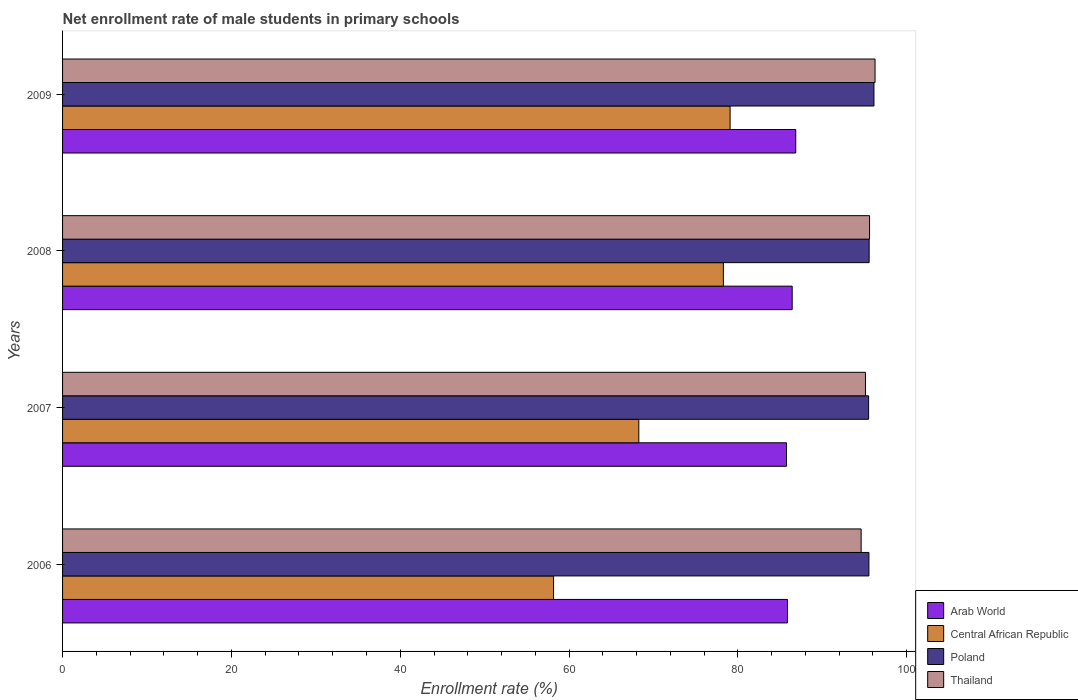How many groups of bars are there?
Your answer should be compact. 4. Are the number of bars on each tick of the Y-axis equal?
Keep it short and to the point. Yes. How many bars are there on the 3rd tick from the top?
Keep it short and to the point. 4. What is the label of the 3rd group of bars from the top?
Your answer should be very brief. 2007. In how many cases, is the number of bars for a given year not equal to the number of legend labels?
Ensure brevity in your answer.  0. What is the net enrollment rate of male students in primary schools in Poland in 2008?
Your answer should be very brief. 95.55. Across all years, what is the maximum net enrollment rate of male students in primary schools in Central African Republic?
Keep it short and to the point. 79.08. Across all years, what is the minimum net enrollment rate of male students in primary schools in Arab World?
Your answer should be very brief. 85.76. In which year was the net enrollment rate of male students in primary schools in Poland maximum?
Ensure brevity in your answer.  2009. In which year was the net enrollment rate of male students in primary schools in Central African Republic minimum?
Offer a terse response. 2006. What is the total net enrollment rate of male students in primary schools in Arab World in the graph?
Make the answer very short. 344.91. What is the difference between the net enrollment rate of male students in primary schools in Thailand in 2006 and that in 2008?
Provide a succinct answer. -1. What is the difference between the net enrollment rate of male students in primary schools in Arab World in 2006 and the net enrollment rate of male students in primary schools in Poland in 2009?
Provide a short and direct response. -10.24. What is the average net enrollment rate of male students in primary schools in Thailand per year?
Your answer should be compact. 95.39. In the year 2007, what is the difference between the net enrollment rate of male students in primary schools in Arab World and net enrollment rate of male students in primary schools in Poland?
Keep it short and to the point. -9.73. In how many years, is the net enrollment rate of male students in primary schools in Arab World greater than 92 %?
Offer a terse response. 0. What is the ratio of the net enrollment rate of male students in primary schools in Poland in 2006 to that in 2008?
Make the answer very short. 1. Is the net enrollment rate of male students in primary schools in Arab World in 2007 less than that in 2008?
Offer a very short reply. Yes. Is the difference between the net enrollment rate of male students in primary schools in Arab World in 2006 and 2007 greater than the difference between the net enrollment rate of male students in primary schools in Poland in 2006 and 2007?
Your answer should be compact. Yes. What is the difference between the highest and the second highest net enrollment rate of male students in primary schools in Poland?
Offer a very short reply. 0.57. What is the difference between the highest and the lowest net enrollment rate of male students in primary schools in Poland?
Your answer should be very brief. 0.63. In how many years, is the net enrollment rate of male students in primary schools in Central African Republic greater than the average net enrollment rate of male students in primary schools in Central African Republic taken over all years?
Your answer should be compact. 2. What does the 4th bar from the top in 2006 represents?
Your response must be concise. Arab World. What does the 4th bar from the bottom in 2009 represents?
Provide a succinct answer. Thailand. Are all the bars in the graph horizontal?
Keep it short and to the point. Yes. How many years are there in the graph?
Offer a very short reply. 4. What is the difference between two consecutive major ticks on the X-axis?
Provide a short and direct response. 20. Are the values on the major ticks of X-axis written in scientific E-notation?
Your answer should be very brief. No. Where does the legend appear in the graph?
Your response must be concise. Bottom right. How are the legend labels stacked?
Offer a very short reply. Vertical. What is the title of the graph?
Keep it short and to the point. Net enrollment rate of male students in primary schools. What is the label or title of the X-axis?
Give a very brief answer. Enrollment rate (%). What is the Enrollment rate (%) of Arab World in 2006?
Offer a very short reply. 85.87. What is the Enrollment rate (%) of Central African Republic in 2006?
Offer a very short reply. 58.16. What is the Enrollment rate (%) in Poland in 2006?
Provide a succinct answer. 95.52. What is the Enrollment rate (%) of Thailand in 2006?
Ensure brevity in your answer.  94.6. What is the Enrollment rate (%) in Arab World in 2007?
Your answer should be very brief. 85.76. What is the Enrollment rate (%) in Central African Republic in 2007?
Give a very brief answer. 68.26. What is the Enrollment rate (%) of Poland in 2007?
Give a very brief answer. 95.48. What is the Enrollment rate (%) of Thailand in 2007?
Provide a short and direct response. 95.11. What is the Enrollment rate (%) of Arab World in 2008?
Make the answer very short. 86.43. What is the Enrollment rate (%) of Central African Republic in 2008?
Make the answer very short. 78.28. What is the Enrollment rate (%) in Poland in 2008?
Make the answer very short. 95.55. What is the Enrollment rate (%) of Thailand in 2008?
Provide a short and direct response. 95.6. What is the Enrollment rate (%) in Arab World in 2009?
Make the answer very short. 86.85. What is the Enrollment rate (%) of Central African Republic in 2009?
Make the answer very short. 79.08. What is the Enrollment rate (%) in Poland in 2009?
Provide a short and direct response. 96.12. What is the Enrollment rate (%) in Thailand in 2009?
Make the answer very short. 96.25. Across all years, what is the maximum Enrollment rate (%) of Arab World?
Provide a succinct answer. 86.85. Across all years, what is the maximum Enrollment rate (%) in Central African Republic?
Keep it short and to the point. 79.08. Across all years, what is the maximum Enrollment rate (%) in Poland?
Make the answer very short. 96.12. Across all years, what is the maximum Enrollment rate (%) in Thailand?
Your answer should be very brief. 96.25. Across all years, what is the minimum Enrollment rate (%) of Arab World?
Make the answer very short. 85.76. Across all years, what is the minimum Enrollment rate (%) of Central African Republic?
Offer a very short reply. 58.16. Across all years, what is the minimum Enrollment rate (%) in Poland?
Make the answer very short. 95.48. Across all years, what is the minimum Enrollment rate (%) of Thailand?
Offer a terse response. 94.6. What is the total Enrollment rate (%) in Arab World in the graph?
Make the answer very short. 344.91. What is the total Enrollment rate (%) in Central African Republic in the graph?
Provide a short and direct response. 283.78. What is the total Enrollment rate (%) in Poland in the graph?
Offer a terse response. 382.67. What is the total Enrollment rate (%) of Thailand in the graph?
Provide a short and direct response. 381.56. What is the difference between the Enrollment rate (%) in Arab World in 2006 and that in 2007?
Keep it short and to the point. 0.12. What is the difference between the Enrollment rate (%) of Central African Republic in 2006 and that in 2007?
Your response must be concise. -10.1. What is the difference between the Enrollment rate (%) of Poland in 2006 and that in 2007?
Provide a succinct answer. 0.04. What is the difference between the Enrollment rate (%) of Thailand in 2006 and that in 2007?
Give a very brief answer. -0.51. What is the difference between the Enrollment rate (%) in Arab World in 2006 and that in 2008?
Ensure brevity in your answer.  -0.56. What is the difference between the Enrollment rate (%) in Central African Republic in 2006 and that in 2008?
Your answer should be very brief. -20.11. What is the difference between the Enrollment rate (%) in Poland in 2006 and that in 2008?
Offer a terse response. -0.03. What is the difference between the Enrollment rate (%) of Thailand in 2006 and that in 2008?
Provide a succinct answer. -1. What is the difference between the Enrollment rate (%) in Arab World in 2006 and that in 2009?
Give a very brief answer. -0.98. What is the difference between the Enrollment rate (%) in Central African Republic in 2006 and that in 2009?
Provide a succinct answer. -20.91. What is the difference between the Enrollment rate (%) of Poland in 2006 and that in 2009?
Keep it short and to the point. -0.6. What is the difference between the Enrollment rate (%) in Thailand in 2006 and that in 2009?
Provide a succinct answer. -1.65. What is the difference between the Enrollment rate (%) in Arab World in 2007 and that in 2008?
Offer a terse response. -0.67. What is the difference between the Enrollment rate (%) of Central African Republic in 2007 and that in 2008?
Your answer should be compact. -10.02. What is the difference between the Enrollment rate (%) of Poland in 2007 and that in 2008?
Give a very brief answer. -0.07. What is the difference between the Enrollment rate (%) of Thailand in 2007 and that in 2008?
Keep it short and to the point. -0.49. What is the difference between the Enrollment rate (%) in Arab World in 2007 and that in 2009?
Offer a very short reply. -1.1. What is the difference between the Enrollment rate (%) of Central African Republic in 2007 and that in 2009?
Provide a short and direct response. -10.81. What is the difference between the Enrollment rate (%) in Poland in 2007 and that in 2009?
Your answer should be very brief. -0.63. What is the difference between the Enrollment rate (%) in Thailand in 2007 and that in 2009?
Your answer should be very brief. -1.13. What is the difference between the Enrollment rate (%) of Arab World in 2008 and that in 2009?
Make the answer very short. -0.42. What is the difference between the Enrollment rate (%) of Central African Republic in 2008 and that in 2009?
Your answer should be compact. -0.8. What is the difference between the Enrollment rate (%) of Poland in 2008 and that in 2009?
Offer a terse response. -0.57. What is the difference between the Enrollment rate (%) in Thailand in 2008 and that in 2009?
Your response must be concise. -0.65. What is the difference between the Enrollment rate (%) of Arab World in 2006 and the Enrollment rate (%) of Central African Republic in 2007?
Your answer should be very brief. 17.61. What is the difference between the Enrollment rate (%) in Arab World in 2006 and the Enrollment rate (%) in Poland in 2007?
Make the answer very short. -9.61. What is the difference between the Enrollment rate (%) in Arab World in 2006 and the Enrollment rate (%) in Thailand in 2007?
Your answer should be compact. -9.24. What is the difference between the Enrollment rate (%) of Central African Republic in 2006 and the Enrollment rate (%) of Poland in 2007?
Keep it short and to the point. -37.32. What is the difference between the Enrollment rate (%) of Central African Republic in 2006 and the Enrollment rate (%) of Thailand in 2007?
Provide a succinct answer. -36.95. What is the difference between the Enrollment rate (%) in Poland in 2006 and the Enrollment rate (%) in Thailand in 2007?
Your response must be concise. 0.41. What is the difference between the Enrollment rate (%) of Arab World in 2006 and the Enrollment rate (%) of Central African Republic in 2008?
Ensure brevity in your answer.  7.6. What is the difference between the Enrollment rate (%) in Arab World in 2006 and the Enrollment rate (%) in Poland in 2008?
Your answer should be compact. -9.68. What is the difference between the Enrollment rate (%) in Arab World in 2006 and the Enrollment rate (%) in Thailand in 2008?
Your response must be concise. -9.72. What is the difference between the Enrollment rate (%) in Central African Republic in 2006 and the Enrollment rate (%) in Poland in 2008?
Make the answer very short. -37.39. What is the difference between the Enrollment rate (%) in Central African Republic in 2006 and the Enrollment rate (%) in Thailand in 2008?
Your response must be concise. -37.43. What is the difference between the Enrollment rate (%) of Poland in 2006 and the Enrollment rate (%) of Thailand in 2008?
Your answer should be compact. -0.08. What is the difference between the Enrollment rate (%) in Arab World in 2006 and the Enrollment rate (%) in Central African Republic in 2009?
Make the answer very short. 6.8. What is the difference between the Enrollment rate (%) in Arab World in 2006 and the Enrollment rate (%) in Poland in 2009?
Your response must be concise. -10.24. What is the difference between the Enrollment rate (%) of Arab World in 2006 and the Enrollment rate (%) of Thailand in 2009?
Offer a very short reply. -10.37. What is the difference between the Enrollment rate (%) in Central African Republic in 2006 and the Enrollment rate (%) in Poland in 2009?
Offer a terse response. -37.95. What is the difference between the Enrollment rate (%) of Central African Republic in 2006 and the Enrollment rate (%) of Thailand in 2009?
Provide a short and direct response. -38.08. What is the difference between the Enrollment rate (%) of Poland in 2006 and the Enrollment rate (%) of Thailand in 2009?
Provide a short and direct response. -0.73. What is the difference between the Enrollment rate (%) of Arab World in 2007 and the Enrollment rate (%) of Central African Republic in 2008?
Give a very brief answer. 7.48. What is the difference between the Enrollment rate (%) in Arab World in 2007 and the Enrollment rate (%) in Poland in 2008?
Offer a very short reply. -9.79. What is the difference between the Enrollment rate (%) of Arab World in 2007 and the Enrollment rate (%) of Thailand in 2008?
Your answer should be very brief. -9.84. What is the difference between the Enrollment rate (%) in Central African Republic in 2007 and the Enrollment rate (%) in Poland in 2008?
Offer a very short reply. -27.29. What is the difference between the Enrollment rate (%) of Central African Republic in 2007 and the Enrollment rate (%) of Thailand in 2008?
Provide a succinct answer. -27.34. What is the difference between the Enrollment rate (%) in Poland in 2007 and the Enrollment rate (%) in Thailand in 2008?
Make the answer very short. -0.11. What is the difference between the Enrollment rate (%) of Arab World in 2007 and the Enrollment rate (%) of Central African Republic in 2009?
Keep it short and to the point. 6.68. What is the difference between the Enrollment rate (%) of Arab World in 2007 and the Enrollment rate (%) of Poland in 2009?
Offer a very short reply. -10.36. What is the difference between the Enrollment rate (%) of Arab World in 2007 and the Enrollment rate (%) of Thailand in 2009?
Provide a succinct answer. -10.49. What is the difference between the Enrollment rate (%) in Central African Republic in 2007 and the Enrollment rate (%) in Poland in 2009?
Your answer should be compact. -27.86. What is the difference between the Enrollment rate (%) in Central African Republic in 2007 and the Enrollment rate (%) in Thailand in 2009?
Provide a succinct answer. -27.98. What is the difference between the Enrollment rate (%) in Poland in 2007 and the Enrollment rate (%) in Thailand in 2009?
Your response must be concise. -0.76. What is the difference between the Enrollment rate (%) of Arab World in 2008 and the Enrollment rate (%) of Central African Republic in 2009?
Provide a short and direct response. 7.35. What is the difference between the Enrollment rate (%) in Arab World in 2008 and the Enrollment rate (%) in Poland in 2009?
Make the answer very short. -9.69. What is the difference between the Enrollment rate (%) in Arab World in 2008 and the Enrollment rate (%) in Thailand in 2009?
Your response must be concise. -9.82. What is the difference between the Enrollment rate (%) in Central African Republic in 2008 and the Enrollment rate (%) in Poland in 2009?
Provide a succinct answer. -17.84. What is the difference between the Enrollment rate (%) of Central African Republic in 2008 and the Enrollment rate (%) of Thailand in 2009?
Provide a succinct answer. -17.97. What is the difference between the Enrollment rate (%) in Poland in 2008 and the Enrollment rate (%) in Thailand in 2009?
Provide a succinct answer. -0.7. What is the average Enrollment rate (%) of Arab World per year?
Provide a succinct answer. 86.23. What is the average Enrollment rate (%) in Central African Republic per year?
Offer a terse response. 70.95. What is the average Enrollment rate (%) of Poland per year?
Keep it short and to the point. 95.67. What is the average Enrollment rate (%) in Thailand per year?
Keep it short and to the point. 95.39. In the year 2006, what is the difference between the Enrollment rate (%) in Arab World and Enrollment rate (%) in Central African Republic?
Your response must be concise. 27.71. In the year 2006, what is the difference between the Enrollment rate (%) in Arab World and Enrollment rate (%) in Poland?
Your answer should be compact. -9.65. In the year 2006, what is the difference between the Enrollment rate (%) in Arab World and Enrollment rate (%) in Thailand?
Your answer should be compact. -8.73. In the year 2006, what is the difference between the Enrollment rate (%) in Central African Republic and Enrollment rate (%) in Poland?
Make the answer very short. -37.36. In the year 2006, what is the difference between the Enrollment rate (%) of Central African Republic and Enrollment rate (%) of Thailand?
Your answer should be very brief. -36.44. In the year 2006, what is the difference between the Enrollment rate (%) in Poland and Enrollment rate (%) in Thailand?
Provide a short and direct response. 0.92. In the year 2007, what is the difference between the Enrollment rate (%) of Arab World and Enrollment rate (%) of Central African Republic?
Give a very brief answer. 17.49. In the year 2007, what is the difference between the Enrollment rate (%) in Arab World and Enrollment rate (%) in Poland?
Ensure brevity in your answer.  -9.73. In the year 2007, what is the difference between the Enrollment rate (%) of Arab World and Enrollment rate (%) of Thailand?
Offer a terse response. -9.36. In the year 2007, what is the difference between the Enrollment rate (%) of Central African Republic and Enrollment rate (%) of Poland?
Provide a short and direct response. -27.22. In the year 2007, what is the difference between the Enrollment rate (%) of Central African Republic and Enrollment rate (%) of Thailand?
Offer a terse response. -26.85. In the year 2007, what is the difference between the Enrollment rate (%) in Poland and Enrollment rate (%) in Thailand?
Your answer should be compact. 0.37. In the year 2008, what is the difference between the Enrollment rate (%) in Arab World and Enrollment rate (%) in Central African Republic?
Provide a short and direct response. 8.15. In the year 2008, what is the difference between the Enrollment rate (%) of Arab World and Enrollment rate (%) of Poland?
Ensure brevity in your answer.  -9.12. In the year 2008, what is the difference between the Enrollment rate (%) in Arab World and Enrollment rate (%) in Thailand?
Your answer should be compact. -9.17. In the year 2008, what is the difference between the Enrollment rate (%) of Central African Republic and Enrollment rate (%) of Poland?
Offer a very short reply. -17.27. In the year 2008, what is the difference between the Enrollment rate (%) in Central African Republic and Enrollment rate (%) in Thailand?
Make the answer very short. -17.32. In the year 2008, what is the difference between the Enrollment rate (%) of Poland and Enrollment rate (%) of Thailand?
Provide a short and direct response. -0.05. In the year 2009, what is the difference between the Enrollment rate (%) of Arab World and Enrollment rate (%) of Central African Republic?
Offer a terse response. 7.78. In the year 2009, what is the difference between the Enrollment rate (%) of Arab World and Enrollment rate (%) of Poland?
Your response must be concise. -9.26. In the year 2009, what is the difference between the Enrollment rate (%) of Arab World and Enrollment rate (%) of Thailand?
Your answer should be compact. -9.39. In the year 2009, what is the difference between the Enrollment rate (%) of Central African Republic and Enrollment rate (%) of Poland?
Provide a succinct answer. -17.04. In the year 2009, what is the difference between the Enrollment rate (%) in Central African Republic and Enrollment rate (%) in Thailand?
Your answer should be very brief. -17.17. In the year 2009, what is the difference between the Enrollment rate (%) in Poland and Enrollment rate (%) in Thailand?
Your answer should be very brief. -0.13. What is the ratio of the Enrollment rate (%) of Arab World in 2006 to that in 2007?
Provide a succinct answer. 1. What is the ratio of the Enrollment rate (%) of Central African Republic in 2006 to that in 2007?
Your answer should be very brief. 0.85. What is the ratio of the Enrollment rate (%) in Thailand in 2006 to that in 2007?
Your answer should be very brief. 0.99. What is the ratio of the Enrollment rate (%) of Central African Republic in 2006 to that in 2008?
Ensure brevity in your answer.  0.74. What is the ratio of the Enrollment rate (%) of Poland in 2006 to that in 2008?
Keep it short and to the point. 1. What is the ratio of the Enrollment rate (%) of Thailand in 2006 to that in 2008?
Ensure brevity in your answer.  0.99. What is the ratio of the Enrollment rate (%) of Arab World in 2006 to that in 2009?
Offer a terse response. 0.99. What is the ratio of the Enrollment rate (%) in Central African Republic in 2006 to that in 2009?
Provide a succinct answer. 0.74. What is the ratio of the Enrollment rate (%) of Poland in 2006 to that in 2009?
Keep it short and to the point. 0.99. What is the ratio of the Enrollment rate (%) of Thailand in 2006 to that in 2009?
Provide a short and direct response. 0.98. What is the ratio of the Enrollment rate (%) in Arab World in 2007 to that in 2008?
Offer a terse response. 0.99. What is the ratio of the Enrollment rate (%) of Central African Republic in 2007 to that in 2008?
Keep it short and to the point. 0.87. What is the ratio of the Enrollment rate (%) of Poland in 2007 to that in 2008?
Make the answer very short. 1. What is the ratio of the Enrollment rate (%) of Arab World in 2007 to that in 2009?
Keep it short and to the point. 0.99. What is the ratio of the Enrollment rate (%) of Central African Republic in 2007 to that in 2009?
Your response must be concise. 0.86. What is the ratio of the Enrollment rate (%) in Poland in 2007 to that in 2009?
Your answer should be very brief. 0.99. What is the ratio of the Enrollment rate (%) in Arab World in 2008 to that in 2009?
Provide a succinct answer. 1. What is the ratio of the Enrollment rate (%) of Poland in 2008 to that in 2009?
Your answer should be compact. 0.99. What is the ratio of the Enrollment rate (%) of Thailand in 2008 to that in 2009?
Offer a terse response. 0.99. What is the difference between the highest and the second highest Enrollment rate (%) of Arab World?
Give a very brief answer. 0.42. What is the difference between the highest and the second highest Enrollment rate (%) of Central African Republic?
Provide a succinct answer. 0.8. What is the difference between the highest and the second highest Enrollment rate (%) of Poland?
Your response must be concise. 0.57. What is the difference between the highest and the second highest Enrollment rate (%) of Thailand?
Offer a very short reply. 0.65. What is the difference between the highest and the lowest Enrollment rate (%) of Arab World?
Give a very brief answer. 1.1. What is the difference between the highest and the lowest Enrollment rate (%) in Central African Republic?
Keep it short and to the point. 20.91. What is the difference between the highest and the lowest Enrollment rate (%) in Poland?
Your response must be concise. 0.63. What is the difference between the highest and the lowest Enrollment rate (%) in Thailand?
Keep it short and to the point. 1.65. 